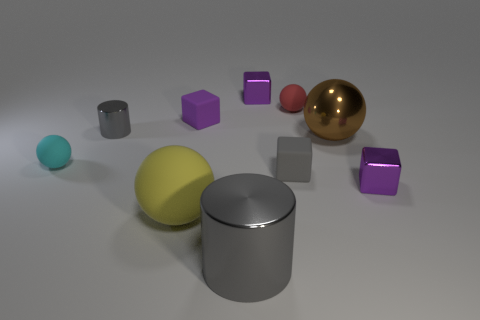How many purple cubes must be subtracted to get 1 purple cubes? 2 Subtract all cylinders. How many objects are left? 8 Subtract all yellow rubber balls. How many balls are left? 3 Subtract 1 cylinders. How many cylinders are left? 1 Subtract all red cylinders. How many red balls are left? 1 Subtract all red rubber balls. Subtract all tiny purple metallic cubes. How many objects are left? 7 Add 6 gray cubes. How many gray cubes are left? 7 Add 5 metal balls. How many metal balls exist? 6 Subtract all cyan balls. How many balls are left? 3 Subtract 1 purple cubes. How many objects are left? 9 